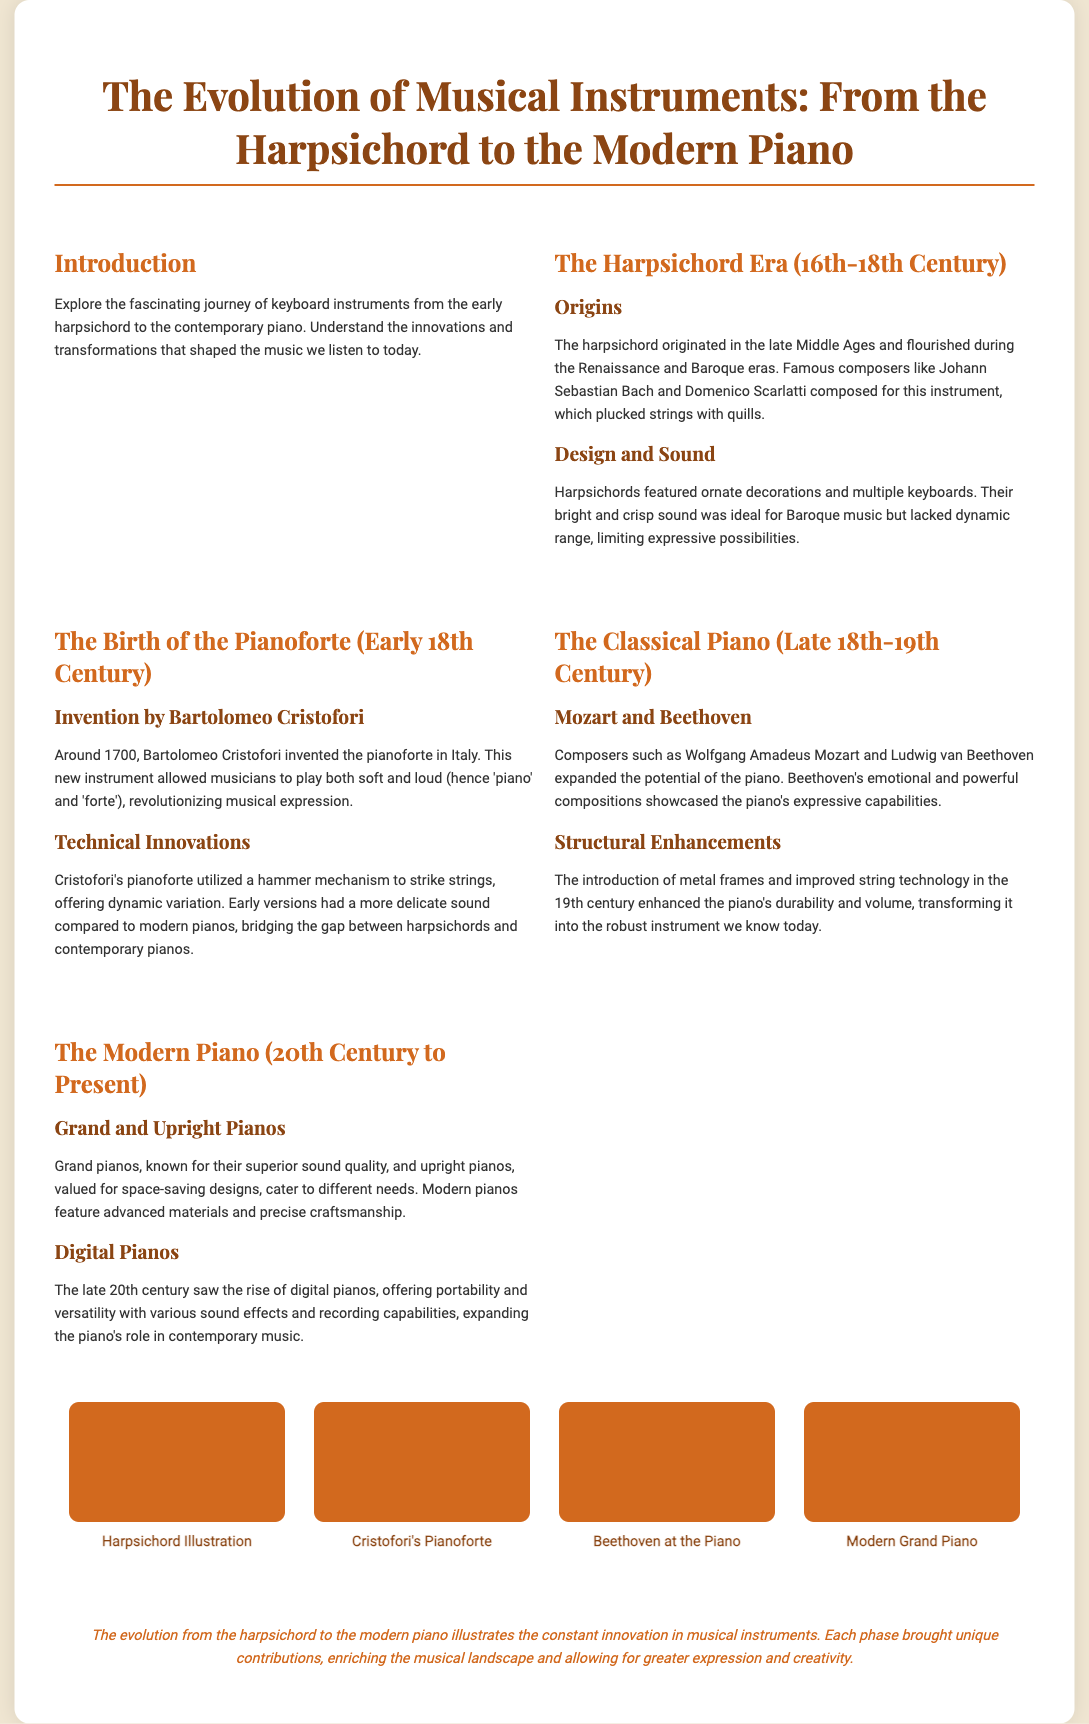What is the main focus of this poster? The poster explores the journey of keyboard instruments from the harpsichord to the modern piano.
Answer: Keyboard instruments Who invented the pianoforte? The document states that Bartolomeo Cristofori invented the pianoforte in Italy.
Answer: Bartolomeo Cristofori Which composers are mentioned as influential in the classical piano era? The poster discusses composers such as Wolfgang Amadeus Mozart and Ludwig van Beethoven.
Answer: Mozart and Beethoven What major material advancement was made to pianos in the 19th century? The introduction of metal frames and improved string technology enhanced the piano's durability and volume.
Answer: Metal frames What is the distinguishing feature of modern grand pianos compared to upright pianos? The poster notes that grand pianos are known for their superior sound quality.
Answer: Superior sound quality In which century did the harpsichord flourish? The harpsichord flourished during the Renaissance and Baroque eras, which spanned the 16th to 18th century.
Answer: 16th-18th century What feature allowed the pianoforte to revolutionize musical expression? The pianoforte allowed musicians to play both soft and loud.
Answer: Soft and loud What innovation is associated with Cristofori's pianoforte? Cristofori's pianoforte utilized a hammer mechanism to strike strings, offering dynamic variation.
Answer: Hammer mechanism 